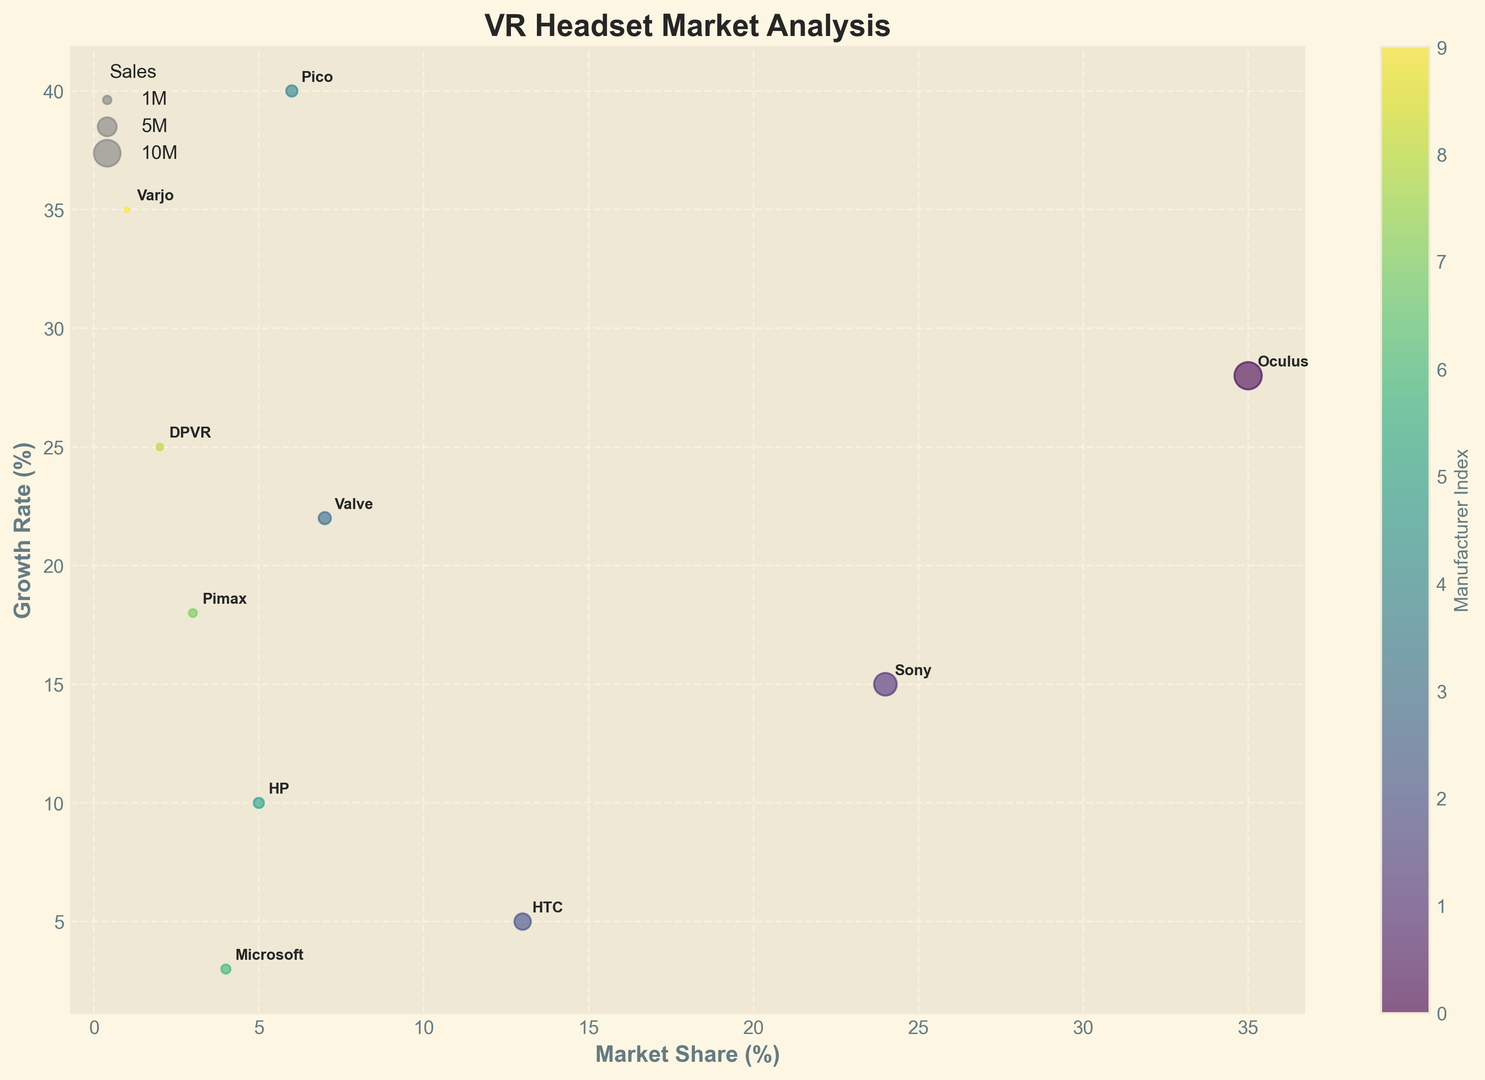What's the manufacturer with the highest market share? Look at the x-axis representing Market Share (%). The bubble farthest to the right corresponds to the highest market share, which is labeled "Oculus".
Answer: Oculus Which manufacturer has the smallest sales figure? The size of the bubble reflects the sales figure. The smallest bubble corresponds to "Varjo."
Answer: Varjo What's the difference in growth rate between HTC and Pico? Identify the y-values for HTC and Pico. HTC has a growth rate of 5%, and Pico has 40%. The difference is 40% - 5%.
Answer: 35% Which three manufacturers have the highest growth rates? Compare the y-values representing Growth Rate (%). Identify the three highest y-values which are for Pico (40%), Varjo (35%), and DPVR (25%).
Answer: Pico, Varjo, DPVR Are there any manufacturers with both low market share and high growth rate? Look for bubbles on the left side of the chart (low market share) and high on the y-axis (high growth rate). Varjo has a 1% market share (very low) and a 35% growth rate (high).
Answer: Varjo Which manufacturer has higher sales, HP or Microsoft? Compare the bubble sizes for HP and Microsoft. HP has 1.5 million sales, whereas Microsoft has 1.2 million sales.
Answer: HP What's the combined market share of Sony and Valve? The x-axis shows Market Share (%). Sony has a 24% market share, and Valve has 7%. Add these together: 24% + 7% = 31%.
Answer: 31% Which manufacturers have a market share less than 5% and growth rate higher than 20%? Look for bubbles in the lower left region (market share under 5%) and high on the y-axis (growth rate above 20%). DPVR (2%) and Varjo (1%) fit this description.
Answer: DPVR, Varjo What's the average sales figure of Oculus, Sony, and HTC combined? Sum the sales figures for Oculus (10.5), Sony (7.2), and HTC (3.8) and divide by 3. (10.5 + 7.2 + 3.8) / 3 = 21.5 / 3.
Answer: 7.17 Which manufacturer, besides Oculus, has the highest growth rates? Excluding Oculus, examine the rest of the manufacturers for their y-values (Growth Rate %). Pico has 40%, which is the highest.
Answer: Pico 